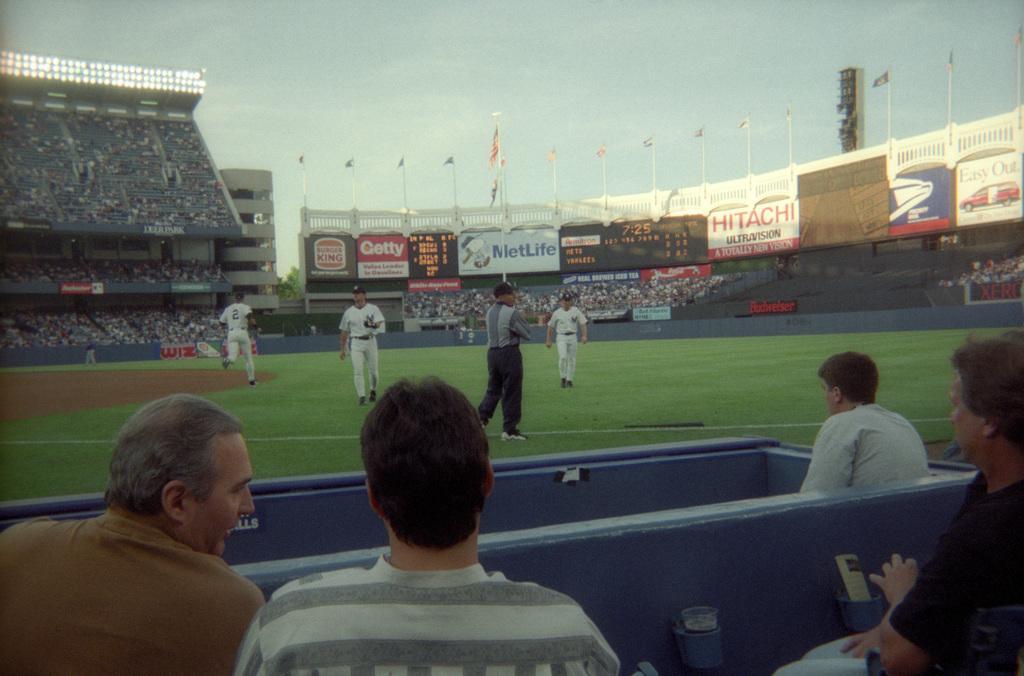Please provide a concise description of this image. In this picture I can see there are a few people standing in the playground and there is a grass and there are a few people sitting at the bottom and there are audience and there are lights, banners and there are flags attached to the flag poles, the sky is clear. 